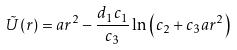<formula> <loc_0><loc_0><loc_500><loc_500>\tilde { U } ( r ) = a r ^ { 2 } - \frac { d _ { 1 } c _ { 1 } } { c _ { 3 } } \ln \left ( c _ { 2 } + c _ { 3 } a r ^ { 2 } \right )</formula> 